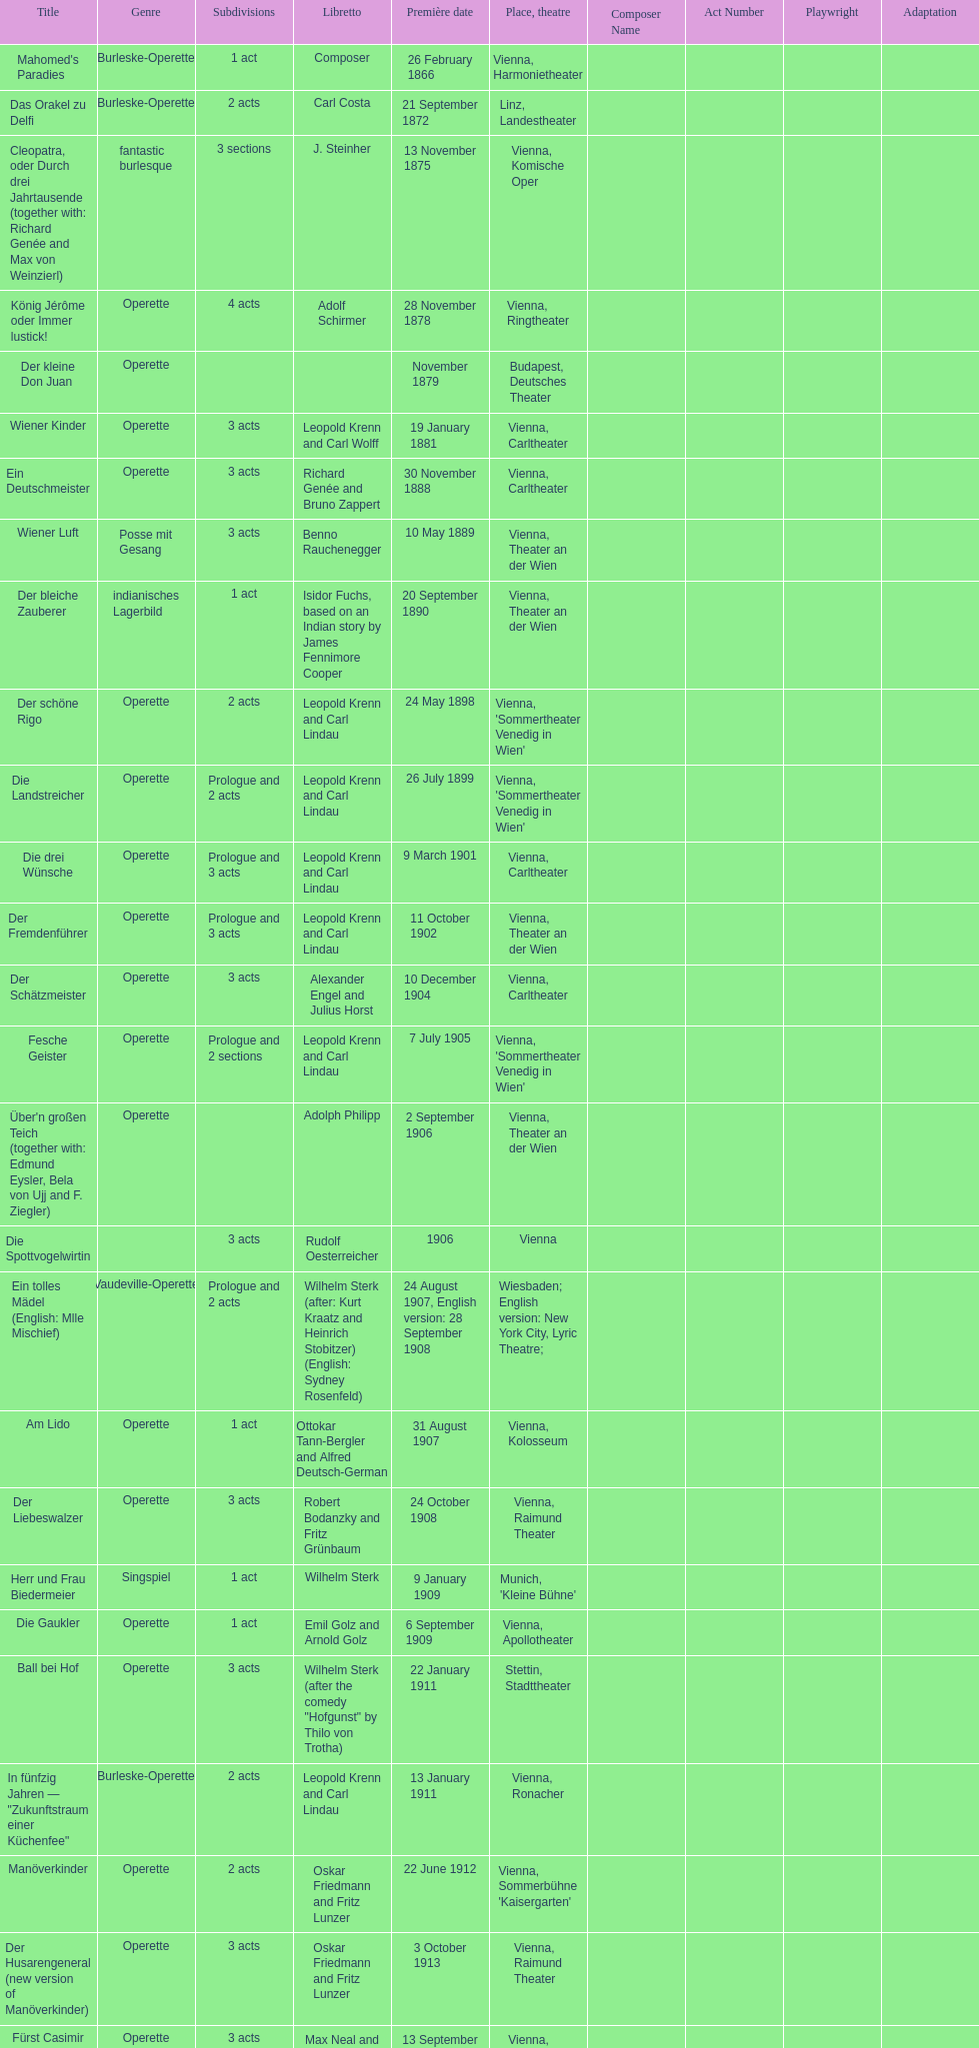Up to which year do all the dates go? 1958. 